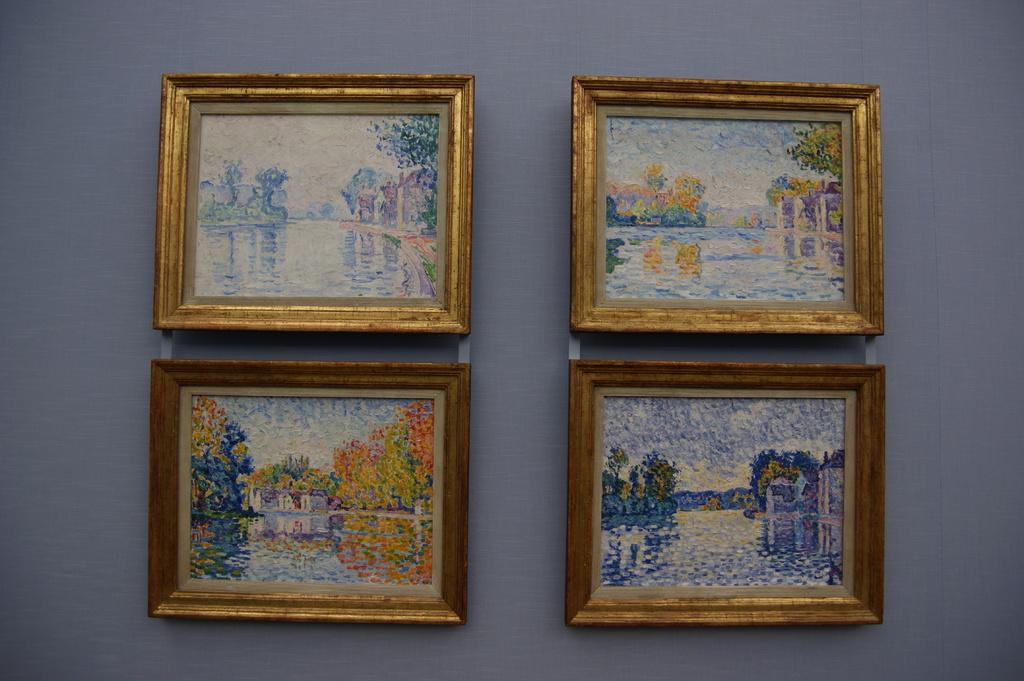How would you summarize this image in a sentence or two? In this picture we can see four golden painting frames is hanging on the purple color wall. 